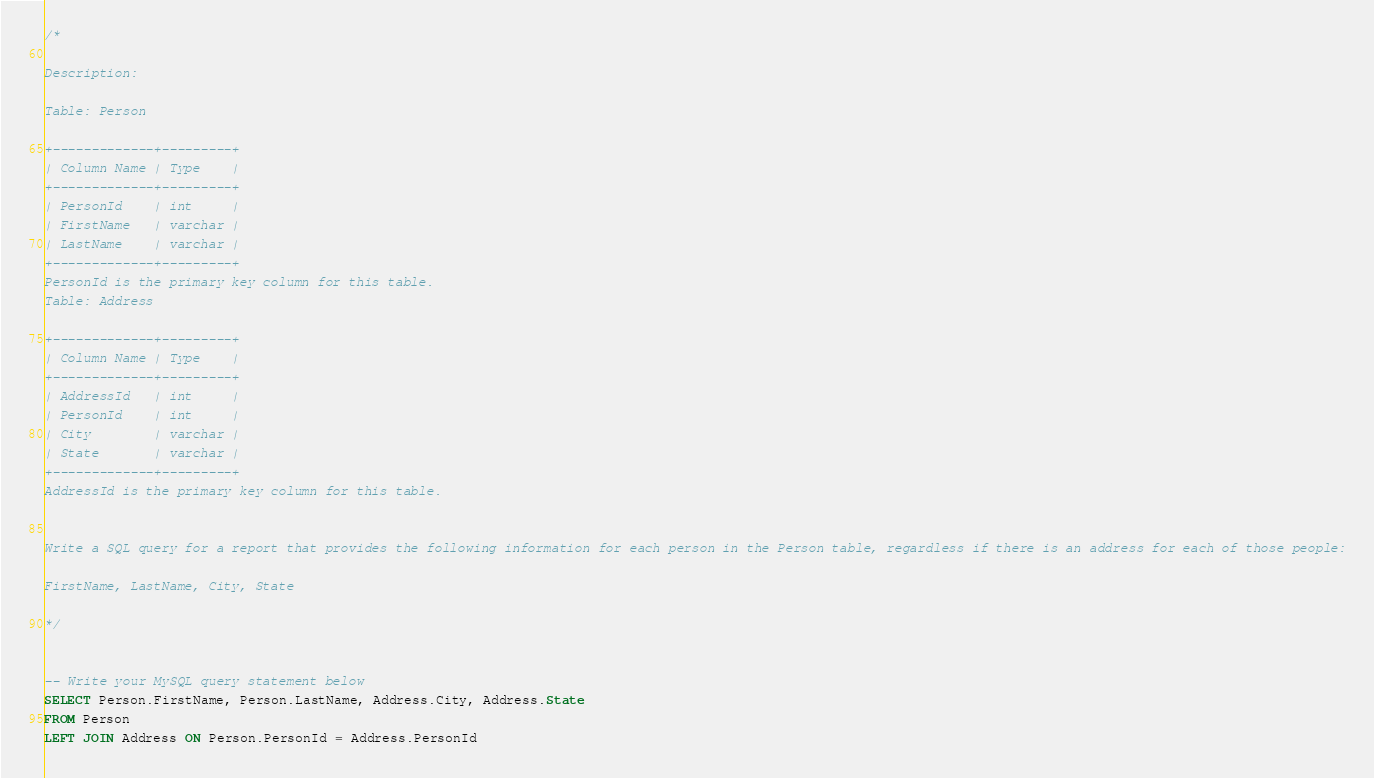<code> <loc_0><loc_0><loc_500><loc_500><_SQL_>/*

Description:

Table: Person

+-------------+---------+
| Column Name | Type    |
+-------------+---------+
| PersonId    | int     |
| FirstName   | varchar |
| LastName    | varchar |
+-------------+---------+
PersonId is the primary key column for this table.
Table: Address

+-------------+---------+
| Column Name | Type    |
+-------------+---------+
| AddressId   | int     |
| PersonId    | int     |
| City        | varchar |
| State       | varchar |
+-------------+---------+
AddressId is the primary key column for this table.
 

Write a SQL query for a report that provides the following information for each person in the Person table, regardless if there is an address for each of those people:

FirstName, LastName, City, State

*/


-- Write your MySQL query statement below
SELECT Person.FirstName, Person.LastName, Address.City, Address.State
FROM Person 
LEFT JOIN Address ON Person.PersonId = Address.PersonId</code> 